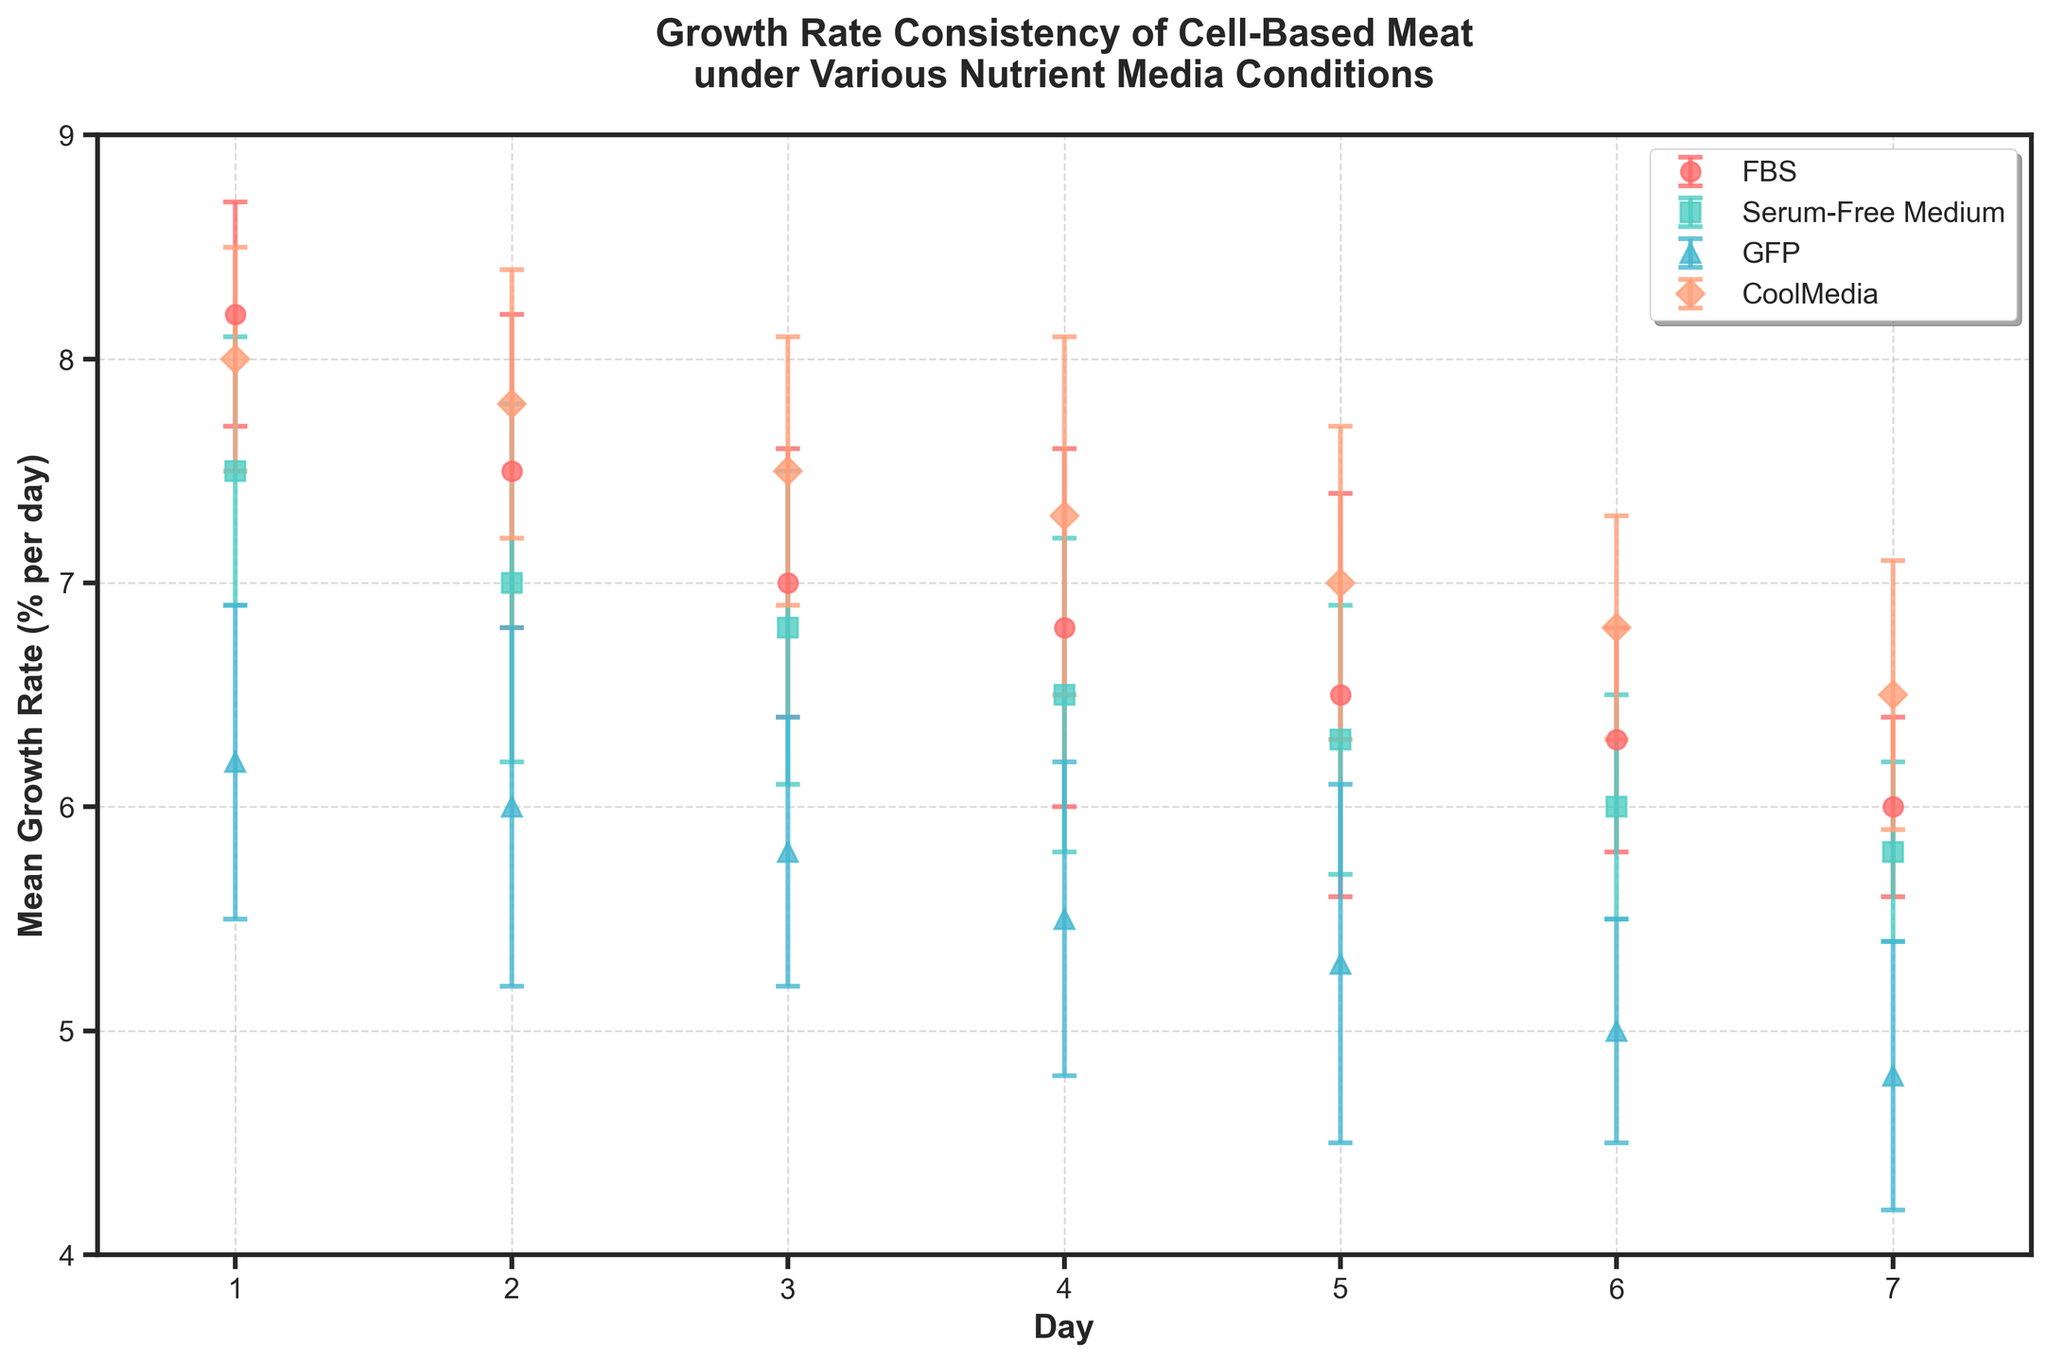What is the title of the figure? The title of the figure is typically located at the top and summarizes the main point of the plot.
Answer: Growth Rate Consistency of Cell-Based Meat under Various Nutrient Media Conditions Which nutrient media condition shows the highest mean growth rate on day 1? To find this, look at the error bars and data points on day 1 and compare the mean growth rates for all nutrient media conditions.
Answer: FBS What is the range of mean growth rates for FBS over the seven days? The range is calculated as the difference between the maximum and minimum mean growth rates for FBS over the seven days recorded. The maximum growth rate for FBS is on day 1 (8.2) and the minimum is on day 7 (6.0), so the range is 8.2 - 6.0 = 2.2.
Answer: 2.2 Which nutrient media condition has the smallest standard deviation in growth rate on day 4? To answer this, compare the lengths of the error bars (which represent standard deviations) for each nutrient media condition on day 4. The shortest error bar corresponds to the smallest standard deviation.
Answer: GFP On which day does the serum-free medium show the lowest mean growth rate, and what is that rate? Locate the points for the serum-free medium across the days. The lowest of these points' mean growth rate, in percentage, corresponds to the answer.
Answer: Day 7, 5.8% How do the growth rates on day 3 compare between FBS and CoolMedia? Compare the mean growth rate values at day 3 for both FBS and CoolMedia by looking at their respective points on the plot.
Answer: FBS (7.0%) is lower than CoolMedia (7.5%) What is the overall trend in the mean growth rate for CoolMedia from day 1 to day 7? To identify the trend, observe the connection of data points for CoolMedia from day 1 to day 7. The growth rates start at 8.0 and gradually decrease to 6.5 by day 7, indicating a decreasing trend.
Answer: Decreasing What's the average mean growth rate for GFP over the seven days? Calculate the average by summing the mean growth rates for GFP across all days and dividing by the number of days. The sum is 6.2 + 6.0 + 5.8 + 5.5 + 5.3 + 5.0 + 4.8 = 38.6. The average is 38.6 / 7 ≈ 5.51.
Answer: 5.51 Which nutrient media shows the most consistent growth rate, and how can you tell? Consistency can be determined by analyzing the lengths of the error bars across all days. The nutrient media with the shortest and most uniform error bars indicates the most consistent growth rate.
Answer: CoolMedia 